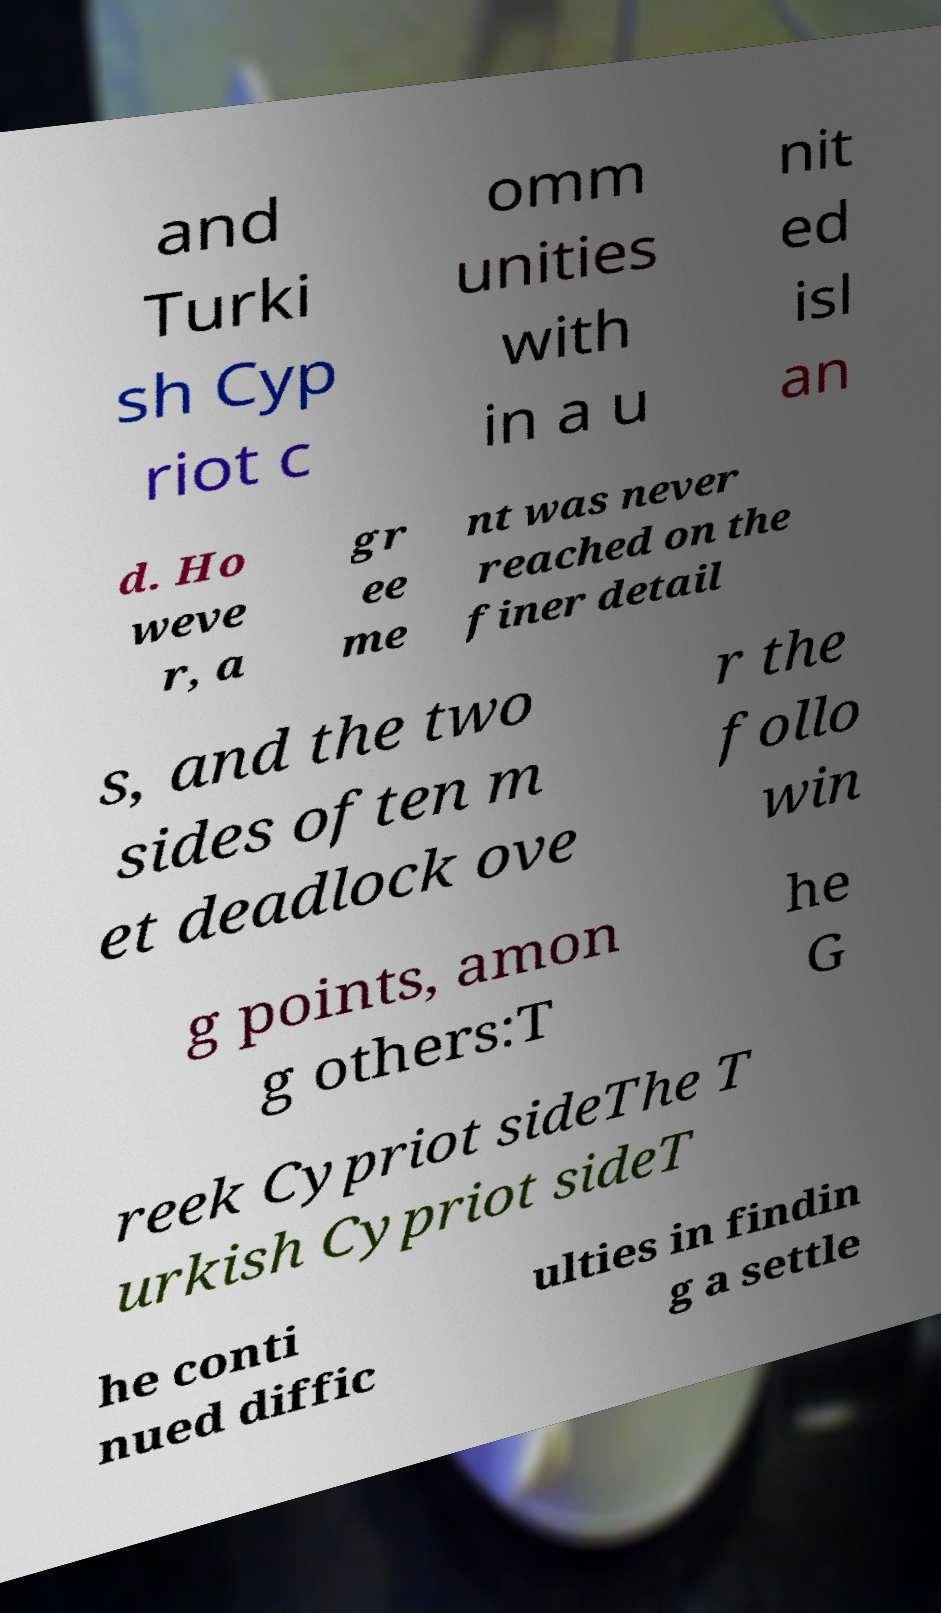For documentation purposes, I need the text within this image transcribed. Could you provide that? and Turki sh Cyp riot c omm unities with in a u nit ed isl an d. Ho weve r, a gr ee me nt was never reached on the finer detail s, and the two sides often m et deadlock ove r the follo win g points, amon g others:T he G reek Cypriot sideThe T urkish Cypriot sideT he conti nued diffic ulties in findin g a settle 